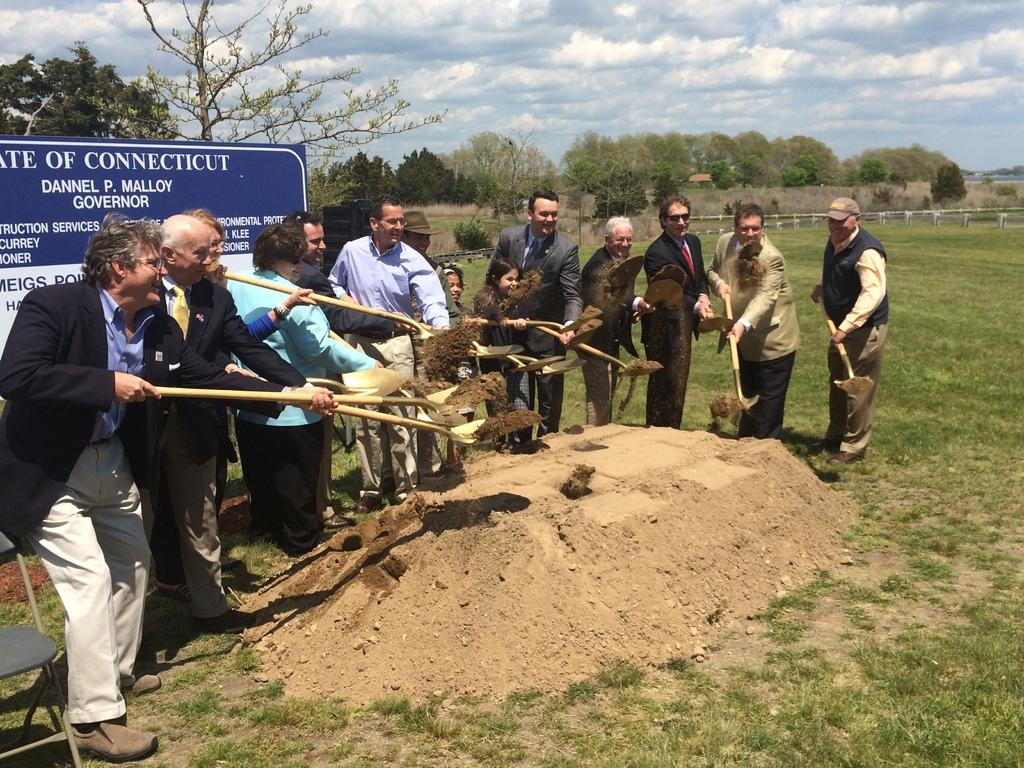Who or what is present in the image? There are people in the image. What are the people holding in their hands? The people are holding spades with mud in them. What is in front of the people? There is mud in front of the people. What can be seen behind the people? There are trees and a wooden fence behind the people. Can you describe another object in the image? There is a board in the image. What type of theory is being discussed by the people in the image? There is no indication in the image that the people are discussing any theories. Can you tell me how many cups are visible in the image? There are no cups present in the image. 